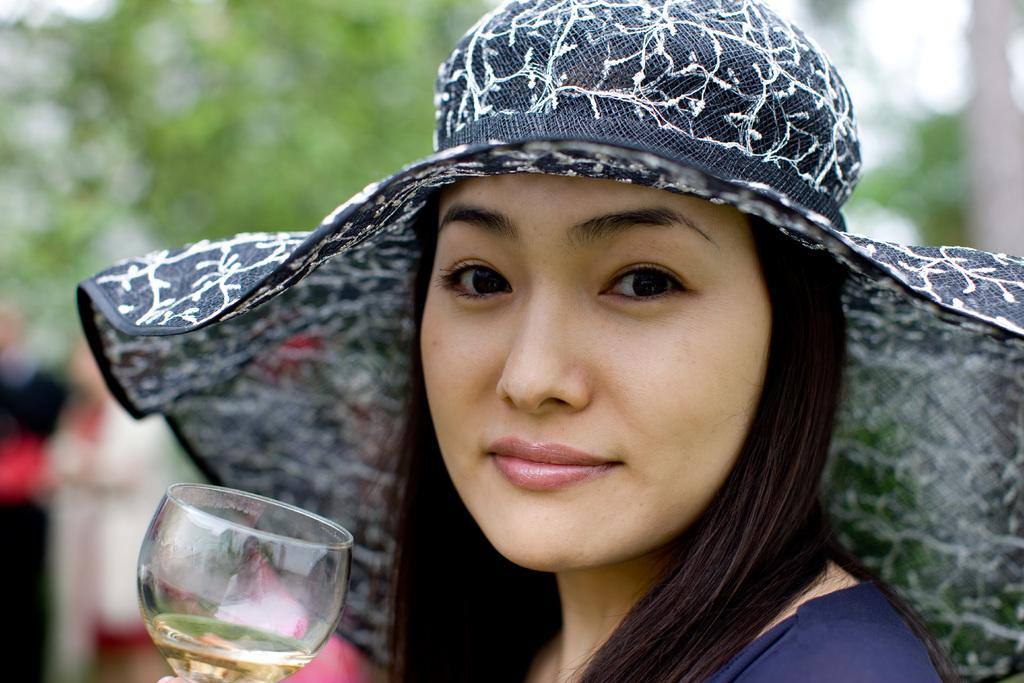Who is present in the image? There is a woman in the image. What is the woman wearing on her head? The woman is wearing a hat. What object can be seen in the image besides the woman? There is a glass in the image. How does the woman show respect to the nut in the image? There is no nut present in the image, so the woman cannot show respect to a nut. 